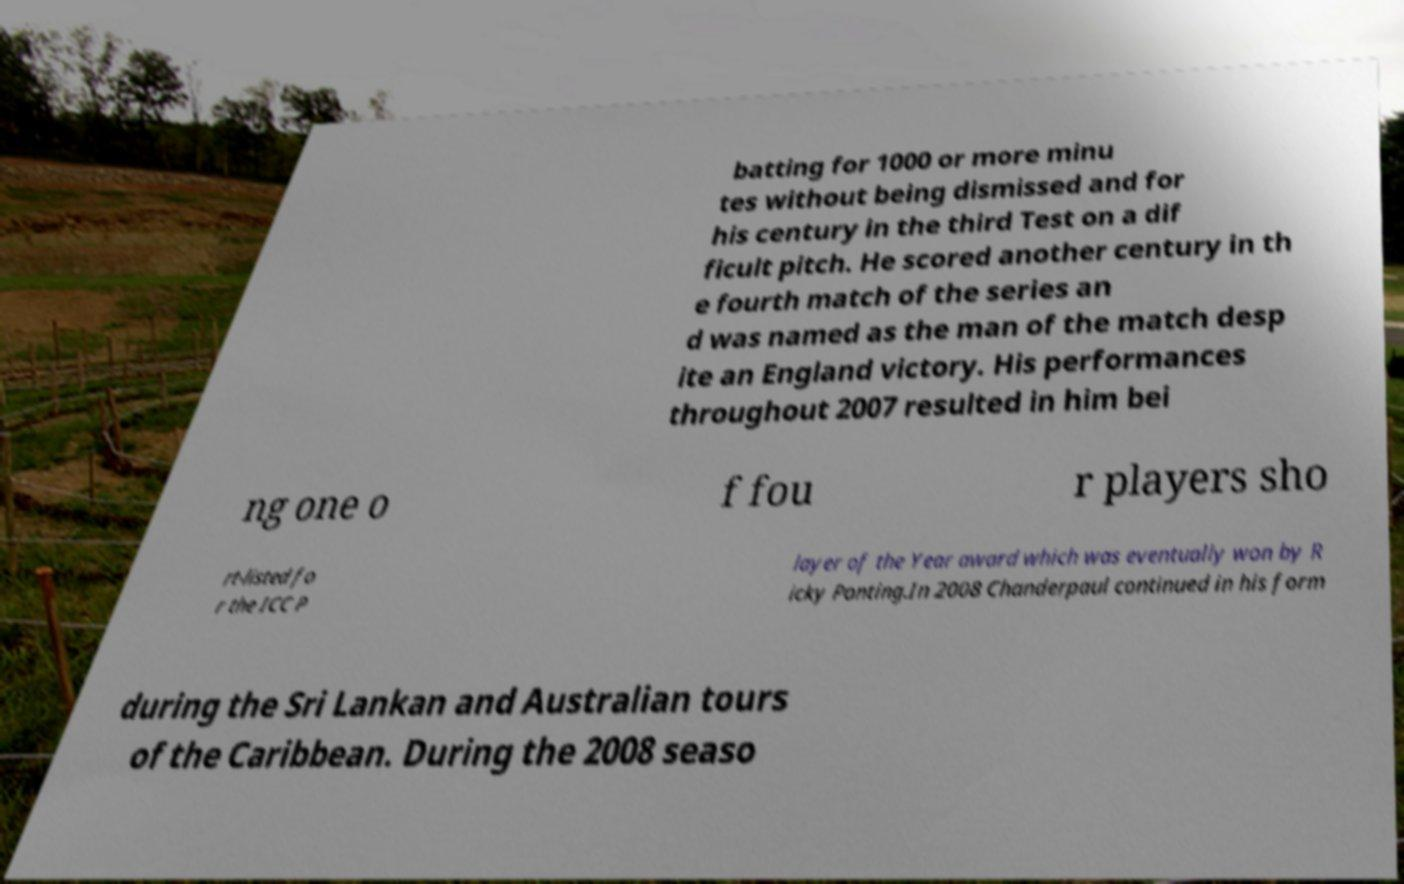What messages or text are displayed in this image? I need them in a readable, typed format. batting for 1000 or more minu tes without being dismissed and for his century in the third Test on a dif ficult pitch. He scored another century in th e fourth match of the series an d was named as the man of the match desp ite an England victory. His performances throughout 2007 resulted in him bei ng one o f fou r players sho rt-listed fo r the ICC P layer of the Year award which was eventually won by R icky Ponting.In 2008 Chanderpaul continued in his form during the Sri Lankan and Australian tours of the Caribbean. During the 2008 seaso 